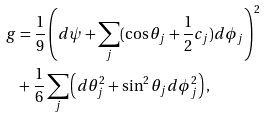<formula> <loc_0><loc_0><loc_500><loc_500>g & = \frac { 1 } { 9 } \left ( d \psi + \sum _ { j } ( \cos \theta _ { j } + \frac { 1 } { 2 } c _ { j } ) d \phi _ { j } \right ) ^ { 2 } \\ & + \frac { 1 } { 6 } \sum _ { j } \left ( d \theta _ { j } ^ { 2 } + \sin ^ { 2 } \theta _ { j } d \phi ^ { 2 } _ { j } \right ) ,</formula> 